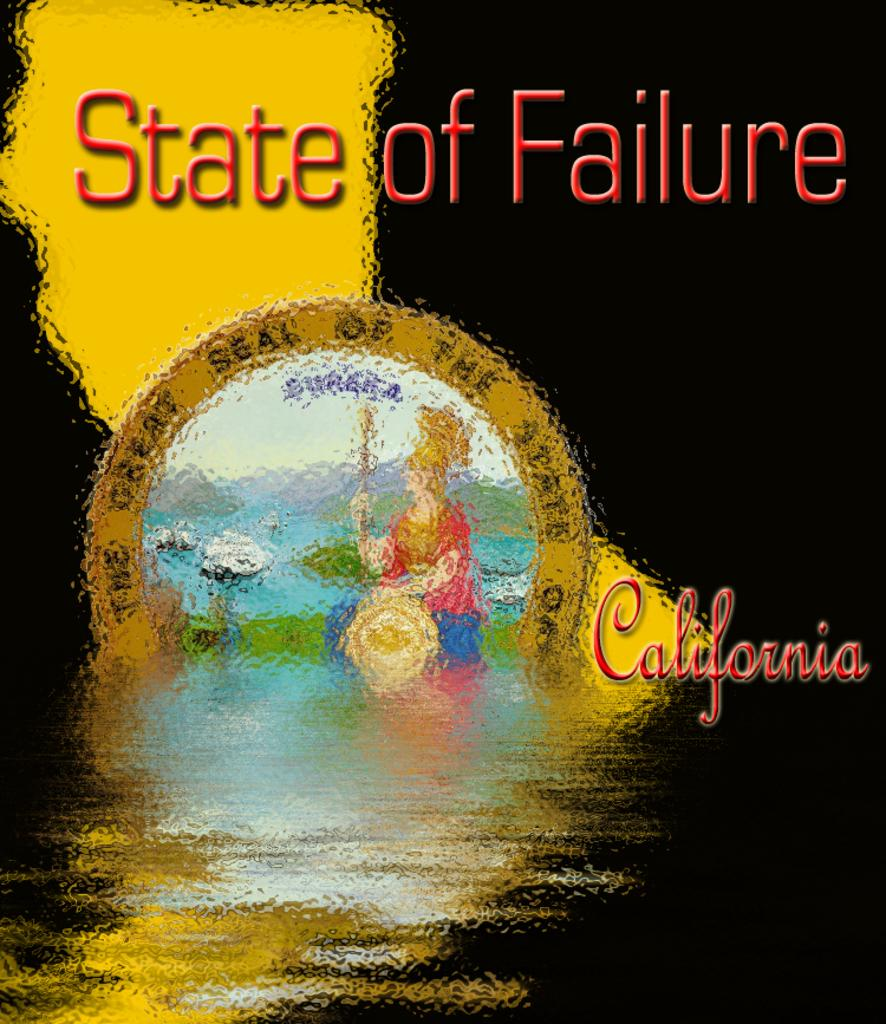<image>
Offer a succinct explanation of the picture presented. The cover of the book titled state of california with the outline of the state in a black background. 